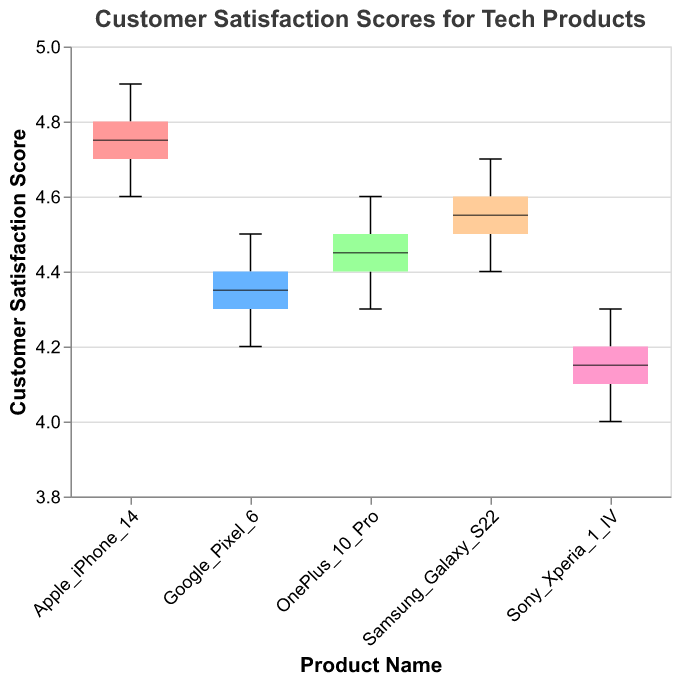What is the title of the plot? The title of the plot is displayed at the top and gives us an overview of the subject of the visualization. It reads "Customer Satisfaction Scores for Tech Products."
Answer: Customer Satisfaction Scores for Tech Products What is the highest customer satisfaction score for the Apple iPhone 14? By observing the box plot for the Apple iPhone 14, the highest score can be found at the top whisker, indicating a value of 4.9.
Answer: 4.9 How many product categories are represented in the plot? Each boxplot represents a product category. By counting the distinct product categories, we find there are five: Apple iPhone 14, Samsung Galaxy S22, Google Pixel 6, Sony Xperia 1 IV, and OnePlus 10 Pro.
Answer: 5 Which product has the lowest median customer satisfaction score? The median is represented by the middle line inside each box. Observing all box plots, the Sony Xperia 1 IV has the lowest median score, indicated by the line inside the box.
Answer: Sony Xperia 1 IV Are any products' satisfaction scores have overlaps in their interquartile ranges? Overlapping interquartile ranges can be identified if the boxes themselves overlap. The Samsung Galaxy S22 and Google Pixel 6 have overlapping interquartile ranges, as do the OnePlus 10 Pro and Google Pixel 6.
Answer: Yes Which product shows the least variability in customer satisfaction scores? Variability is seen as the range between the lower and upper whiskers. The Apple iPhone 14 has the least variability, with tight whiskers indicating closely grouped scores.
Answer: Apple iPhone 14 How does the median score for the Samsung Galaxy S22 compare to the OnePlus 10 Pro? Compare the median lines inside each box. Both Samsung Galaxy S22 and OnePlus 10 Pro have strong median lines, but OnePlus 10 Pro's median score is slightly higher than the Samsung Galaxy S22.
Answer: OnePlus 10 Pro is higher What score marks the lower end of the interquartile range for the Google Pixel 6? Find the bottom of the box for Google Pixel 6, which represents the first quartile. The score at this point is 4.3.
Answer: 4.3 Which product category has the widest notch in the middle of the box plot? The notch represents the confidence interval around the median. The Google Pixel 6 has the widest notch among the products.
Answer: Google Pixel 6 What is the range of customer satisfaction scores for the OnePlus 10 Pro? The range is found by subtracting the lowest score (bottom whisker) from the highest score (top whisker). For OnePlus 10 Pro, it ranges from 4.3 to 4.6, so 4.6 - 4.3 = 0.3.
Answer: 0.3 